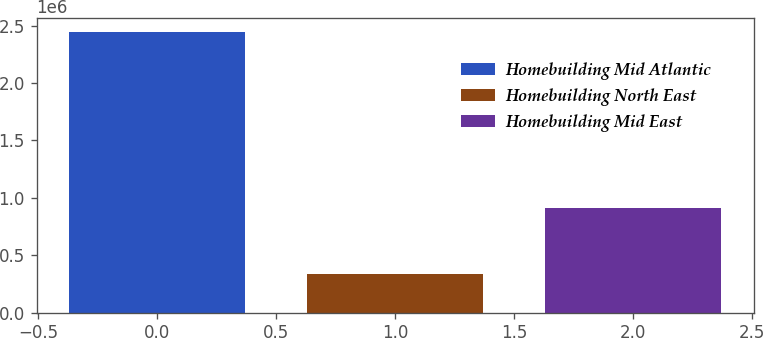Convert chart to OTSL. <chart><loc_0><loc_0><loc_500><loc_500><bar_chart><fcel>Homebuilding Mid Atlantic<fcel>Homebuilding North East<fcel>Homebuilding Mid East<nl><fcel>2.43939e+06<fcel>332681<fcel>908198<nl></chart> 